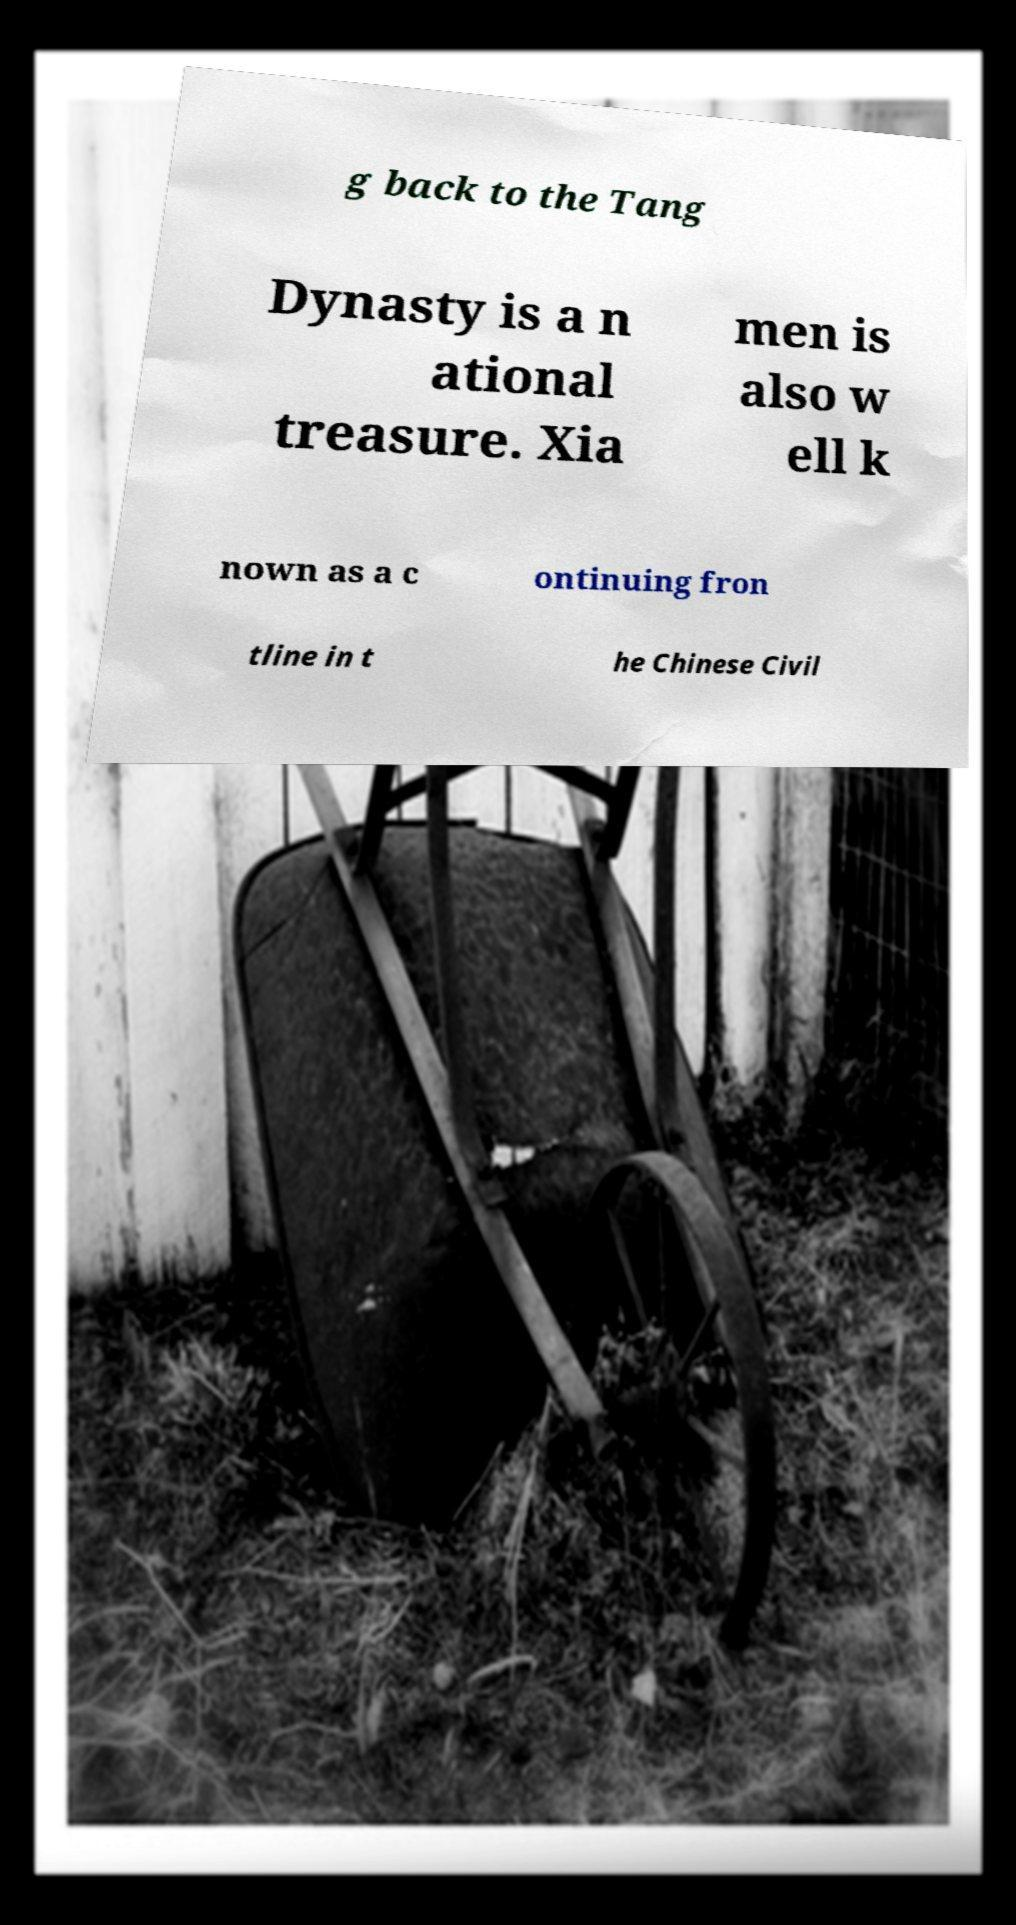Please read and relay the text visible in this image. What does it say? g back to the Tang Dynasty is a n ational treasure. Xia men is also w ell k nown as a c ontinuing fron tline in t he Chinese Civil 